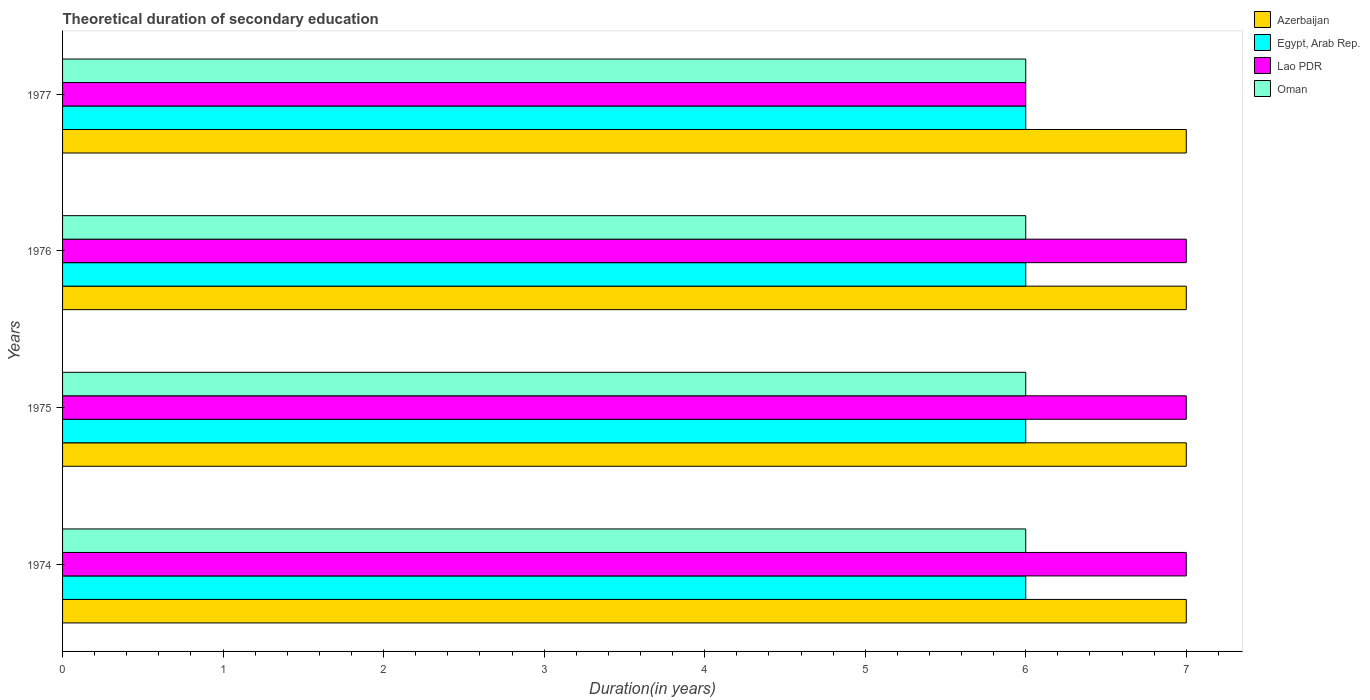Are the number of bars per tick equal to the number of legend labels?
Keep it short and to the point. Yes. How many bars are there on the 2nd tick from the top?
Your response must be concise. 4. How many bars are there on the 1st tick from the bottom?
Your response must be concise. 4. What is the label of the 3rd group of bars from the top?
Ensure brevity in your answer.  1975. Across all years, what is the maximum total theoretical duration of secondary education in Lao PDR?
Your response must be concise. 7. In which year was the total theoretical duration of secondary education in Lao PDR maximum?
Provide a succinct answer. 1974. In which year was the total theoretical duration of secondary education in Egypt, Arab Rep. minimum?
Give a very brief answer. 1974. What is the total total theoretical duration of secondary education in Egypt, Arab Rep. in the graph?
Make the answer very short. 24. What is the difference between the total theoretical duration of secondary education in Lao PDR in 1976 and that in 1977?
Provide a succinct answer. 1. In how many years, is the total theoretical duration of secondary education in Egypt, Arab Rep. greater than 2.4 years?
Provide a succinct answer. 4. What is the difference between the highest and the second highest total theoretical duration of secondary education in Lao PDR?
Your answer should be very brief. 0. What is the difference between the highest and the lowest total theoretical duration of secondary education in Lao PDR?
Offer a terse response. 1. Is the sum of the total theoretical duration of secondary education in Oman in 1974 and 1977 greater than the maximum total theoretical duration of secondary education in Egypt, Arab Rep. across all years?
Your response must be concise. Yes. Is it the case that in every year, the sum of the total theoretical duration of secondary education in Egypt, Arab Rep. and total theoretical duration of secondary education in Azerbaijan is greater than the sum of total theoretical duration of secondary education in Oman and total theoretical duration of secondary education in Lao PDR?
Provide a succinct answer. No. What does the 1st bar from the top in 1975 represents?
Your response must be concise. Oman. What does the 1st bar from the bottom in 1977 represents?
Your answer should be very brief. Azerbaijan. How many bars are there?
Your response must be concise. 16. Are the values on the major ticks of X-axis written in scientific E-notation?
Ensure brevity in your answer.  No. Does the graph contain any zero values?
Your answer should be very brief. No. Does the graph contain grids?
Offer a terse response. No. How many legend labels are there?
Your answer should be compact. 4. How are the legend labels stacked?
Give a very brief answer. Vertical. What is the title of the graph?
Ensure brevity in your answer.  Theoretical duration of secondary education. Does "New Zealand" appear as one of the legend labels in the graph?
Your answer should be very brief. No. What is the label or title of the X-axis?
Give a very brief answer. Duration(in years). What is the label or title of the Y-axis?
Provide a succinct answer. Years. What is the Duration(in years) in Azerbaijan in 1975?
Give a very brief answer. 7. What is the Duration(in years) in Egypt, Arab Rep. in 1975?
Your answer should be compact. 6. What is the Duration(in years) in Oman in 1976?
Your answer should be compact. 6. What is the Duration(in years) of Lao PDR in 1977?
Provide a short and direct response. 6. What is the Duration(in years) of Oman in 1977?
Give a very brief answer. 6. Across all years, what is the maximum Duration(in years) of Lao PDR?
Offer a terse response. 7. Across all years, what is the minimum Duration(in years) of Azerbaijan?
Offer a terse response. 7. Across all years, what is the minimum Duration(in years) in Egypt, Arab Rep.?
Provide a short and direct response. 6. Across all years, what is the minimum Duration(in years) in Lao PDR?
Give a very brief answer. 6. Across all years, what is the minimum Duration(in years) in Oman?
Your response must be concise. 6. What is the total Duration(in years) in Azerbaijan in the graph?
Offer a very short reply. 28. What is the total Duration(in years) of Lao PDR in the graph?
Keep it short and to the point. 27. What is the difference between the Duration(in years) in Azerbaijan in 1974 and that in 1975?
Make the answer very short. 0. What is the difference between the Duration(in years) of Lao PDR in 1974 and that in 1975?
Provide a short and direct response. 0. What is the difference between the Duration(in years) in Oman in 1974 and that in 1975?
Ensure brevity in your answer.  0. What is the difference between the Duration(in years) of Egypt, Arab Rep. in 1974 and that in 1976?
Your response must be concise. 0. What is the difference between the Duration(in years) in Lao PDR in 1974 and that in 1976?
Your response must be concise. 0. What is the difference between the Duration(in years) of Azerbaijan in 1974 and that in 1977?
Provide a succinct answer. 0. What is the difference between the Duration(in years) in Egypt, Arab Rep. in 1974 and that in 1977?
Ensure brevity in your answer.  0. What is the difference between the Duration(in years) of Lao PDR in 1974 and that in 1977?
Keep it short and to the point. 1. What is the difference between the Duration(in years) of Lao PDR in 1975 and that in 1976?
Provide a succinct answer. 0. What is the difference between the Duration(in years) in Oman in 1975 and that in 1976?
Your answer should be very brief. 0. What is the difference between the Duration(in years) in Egypt, Arab Rep. in 1976 and that in 1977?
Your response must be concise. 0. What is the difference between the Duration(in years) in Lao PDR in 1976 and that in 1977?
Your response must be concise. 1. What is the difference between the Duration(in years) of Oman in 1976 and that in 1977?
Your answer should be compact. 0. What is the difference between the Duration(in years) in Azerbaijan in 1974 and the Duration(in years) in Lao PDR in 1976?
Ensure brevity in your answer.  0. What is the difference between the Duration(in years) in Azerbaijan in 1974 and the Duration(in years) in Oman in 1976?
Ensure brevity in your answer.  1. What is the difference between the Duration(in years) in Egypt, Arab Rep. in 1974 and the Duration(in years) in Lao PDR in 1976?
Provide a short and direct response. -1. What is the difference between the Duration(in years) in Azerbaijan in 1974 and the Duration(in years) in Lao PDR in 1977?
Give a very brief answer. 1. What is the difference between the Duration(in years) of Egypt, Arab Rep. in 1974 and the Duration(in years) of Lao PDR in 1977?
Your answer should be very brief. 0. What is the difference between the Duration(in years) in Azerbaijan in 1975 and the Duration(in years) in Egypt, Arab Rep. in 1976?
Ensure brevity in your answer.  1. What is the difference between the Duration(in years) of Azerbaijan in 1975 and the Duration(in years) of Oman in 1976?
Provide a short and direct response. 1. What is the difference between the Duration(in years) of Egypt, Arab Rep. in 1975 and the Duration(in years) of Lao PDR in 1976?
Provide a succinct answer. -1. What is the difference between the Duration(in years) in Egypt, Arab Rep. in 1975 and the Duration(in years) in Oman in 1976?
Your answer should be very brief. 0. What is the difference between the Duration(in years) of Lao PDR in 1975 and the Duration(in years) of Oman in 1976?
Give a very brief answer. 1. What is the difference between the Duration(in years) in Azerbaijan in 1975 and the Duration(in years) in Egypt, Arab Rep. in 1977?
Ensure brevity in your answer.  1. What is the difference between the Duration(in years) in Azerbaijan in 1975 and the Duration(in years) in Lao PDR in 1977?
Make the answer very short. 1. What is the difference between the Duration(in years) of Azerbaijan in 1975 and the Duration(in years) of Oman in 1977?
Provide a succinct answer. 1. What is the difference between the Duration(in years) in Egypt, Arab Rep. in 1975 and the Duration(in years) in Oman in 1977?
Provide a short and direct response. 0. What is the difference between the Duration(in years) of Lao PDR in 1975 and the Duration(in years) of Oman in 1977?
Give a very brief answer. 1. What is the difference between the Duration(in years) in Azerbaijan in 1976 and the Duration(in years) in Egypt, Arab Rep. in 1977?
Make the answer very short. 1. What is the difference between the Duration(in years) in Azerbaijan in 1976 and the Duration(in years) in Oman in 1977?
Your answer should be very brief. 1. What is the difference between the Duration(in years) in Egypt, Arab Rep. in 1976 and the Duration(in years) in Lao PDR in 1977?
Your answer should be compact. 0. What is the difference between the Duration(in years) of Egypt, Arab Rep. in 1976 and the Duration(in years) of Oman in 1977?
Offer a terse response. 0. What is the average Duration(in years) in Lao PDR per year?
Ensure brevity in your answer.  6.75. What is the average Duration(in years) of Oman per year?
Provide a succinct answer. 6. In the year 1974, what is the difference between the Duration(in years) of Azerbaijan and Duration(in years) of Egypt, Arab Rep.?
Your answer should be compact. 1. In the year 1974, what is the difference between the Duration(in years) in Azerbaijan and Duration(in years) in Oman?
Give a very brief answer. 1. In the year 1974, what is the difference between the Duration(in years) in Egypt, Arab Rep. and Duration(in years) in Lao PDR?
Offer a terse response. -1. In the year 1975, what is the difference between the Duration(in years) of Azerbaijan and Duration(in years) of Lao PDR?
Ensure brevity in your answer.  0. In the year 1975, what is the difference between the Duration(in years) of Egypt, Arab Rep. and Duration(in years) of Lao PDR?
Provide a short and direct response. -1. In the year 1975, what is the difference between the Duration(in years) in Egypt, Arab Rep. and Duration(in years) in Oman?
Make the answer very short. 0. In the year 1975, what is the difference between the Duration(in years) in Lao PDR and Duration(in years) in Oman?
Your response must be concise. 1. In the year 1976, what is the difference between the Duration(in years) in Azerbaijan and Duration(in years) in Egypt, Arab Rep.?
Your answer should be compact. 1. In the year 1976, what is the difference between the Duration(in years) of Azerbaijan and Duration(in years) of Oman?
Offer a terse response. 1. In the year 1976, what is the difference between the Duration(in years) of Egypt, Arab Rep. and Duration(in years) of Oman?
Give a very brief answer. 0. In the year 1977, what is the difference between the Duration(in years) in Azerbaijan and Duration(in years) in Lao PDR?
Ensure brevity in your answer.  1. In the year 1977, what is the difference between the Duration(in years) of Azerbaijan and Duration(in years) of Oman?
Your answer should be very brief. 1. In the year 1977, what is the difference between the Duration(in years) of Egypt, Arab Rep. and Duration(in years) of Lao PDR?
Your answer should be compact. 0. What is the ratio of the Duration(in years) in Egypt, Arab Rep. in 1974 to that in 1975?
Your answer should be very brief. 1. What is the ratio of the Duration(in years) in Egypt, Arab Rep. in 1974 to that in 1976?
Keep it short and to the point. 1. What is the ratio of the Duration(in years) in Lao PDR in 1974 to that in 1976?
Make the answer very short. 1. What is the ratio of the Duration(in years) in Azerbaijan in 1974 to that in 1977?
Your answer should be compact. 1. What is the ratio of the Duration(in years) of Oman in 1974 to that in 1977?
Give a very brief answer. 1. What is the ratio of the Duration(in years) in Lao PDR in 1975 to that in 1976?
Offer a very short reply. 1. What is the ratio of the Duration(in years) of Azerbaijan in 1975 to that in 1977?
Keep it short and to the point. 1. What is the difference between the highest and the second highest Duration(in years) of Azerbaijan?
Keep it short and to the point. 0. What is the difference between the highest and the second highest Duration(in years) in Lao PDR?
Keep it short and to the point. 0. What is the difference between the highest and the lowest Duration(in years) in Azerbaijan?
Offer a very short reply. 0. What is the difference between the highest and the lowest Duration(in years) in Egypt, Arab Rep.?
Provide a succinct answer. 0. What is the difference between the highest and the lowest Duration(in years) in Lao PDR?
Offer a very short reply. 1. What is the difference between the highest and the lowest Duration(in years) in Oman?
Offer a very short reply. 0. 